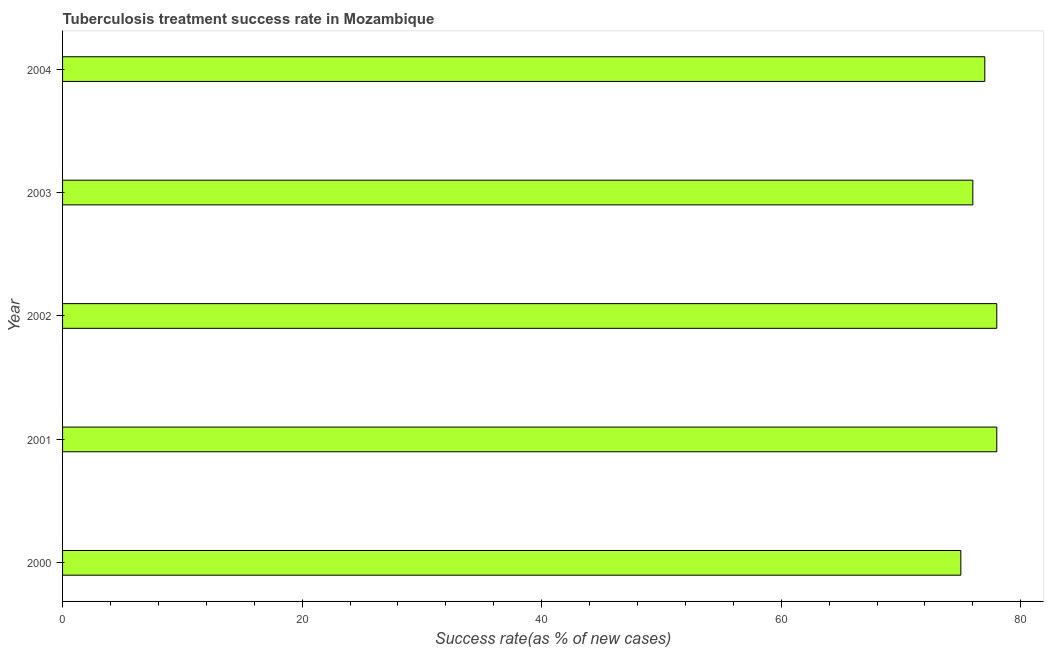Does the graph contain any zero values?
Offer a very short reply. No. Does the graph contain grids?
Give a very brief answer. No. What is the title of the graph?
Your answer should be compact. Tuberculosis treatment success rate in Mozambique. What is the label or title of the X-axis?
Provide a succinct answer. Success rate(as % of new cases). What is the label or title of the Y-axis?
Offer a very short reply. Year. What is the tuberculosis treatment success rate in 2003?
Provide a short and direct response. 76. Across all years, what is the maximum tuberculosis treatment success rate?
Offer a terse response. 78. In which year was the tuberculosis treatment success rate minimum?
Offer a very short reply. 2000. What is the sum of the tuberculosis treatment success rate?
Provide a short and direct response. 384. What is the average tuberculosis treatment success rate per year?
Your answer should be compact. 76. In how many years, is the tuberculosis treatment success rate greater than 32 %?
Keep it short and to the point. 5. Is the difference between the tuberculosis treatment success rate in 2000 and 2004 greater than the difference between any two years?
Keep it short and to the point. No. What is the difference between the highest and the lowest tuberculosis treatment success rate?
Provide a succinct answer. 3. In how many years, is the tuberculosis treatment success rate greater than the average tuberculosis treatment success rate taken over all years?
Your answer should be compact. 3. How many bars are there?
Make the answer very short. 5. Are all the bars in the graph horizontal?
Provide a succinct answer. Yes. How many years are there in the graph?
Ensure brevity in your answer.  5. What is the difference between two consecutive major ticks on the X-axis?
Your answer should be very brief. 20. Are the values on the major ticks of X-axis written in scientific E-notation?
Your answer should be very brief. No. What is the Success rate(as % of new cases) of 2000?
Your answer should be compact. 75. What is the Success rate(as % of new cases) in 2003?
Offer a very short reply. 76. What is the difference between the Success rate(as % of new cases) in 2000 and 2002?
Your answer should be very brief. -3. What is the difference between the Success rate(as % of new cases) in 2003 and 2004?
Ensure brevity in your answer.  -1. What is the ratio of the Success rate(as % of new cases) in 2000 to that in 2001?
Offer a terse response. 0.96. What is the ratio of the Success rate(as % of new cases) in 2000 to that in 2004?
Your response must be concise. 0.97. What is the ratio of the Success rate(as % of new cases) in 2001 to that in 2003?
Ensure brevity in your answer.  1.03. What is the ratio of the Success rate(as % of new cases) in 2002 to that in 2003?
Provide a succinct answer. 1.03. What is the ratio of the Success rate(as % of new cases) in 2002 to that in 2004?
Your answer should be very brief. 1.01. What is the ratio of the Success rate(as % of new cases) in 2003 to that in 2004?
Keep it short and to the point. 0.99. 